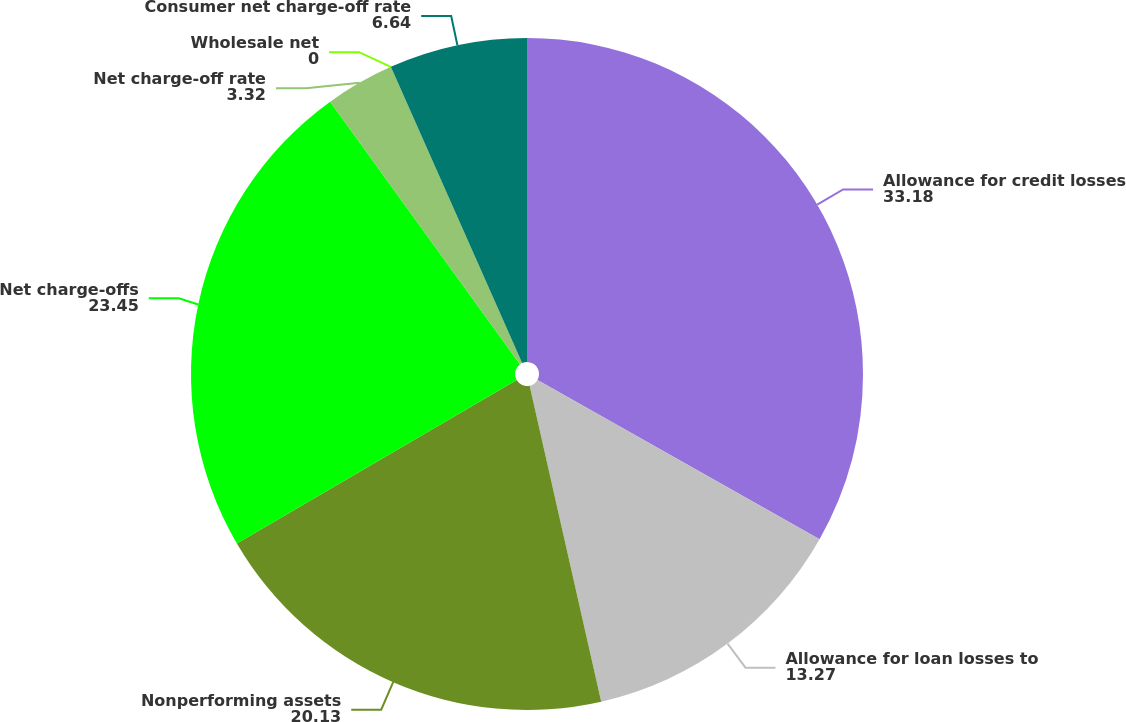Convert chart. <chart><loc_0><loc_0><loc_500><loc_500><pie_chart><fcel>Allowance for credit losses<fcel>Allowance for loan losses to<fcel>Nonperforming assets<fcel>Net charge-offs<fcel>Net charge-off rate<fcel>Wholesale net<fcel>Consumer net charge-off rate<nl><fcel>33.18%<fcel>13.27%<fcel>20.13%<fcel>23.45%<fcel>3.32%<fcel>0.0%<fcel>6.64%<nl></chart> 